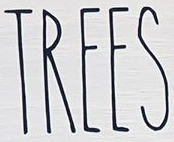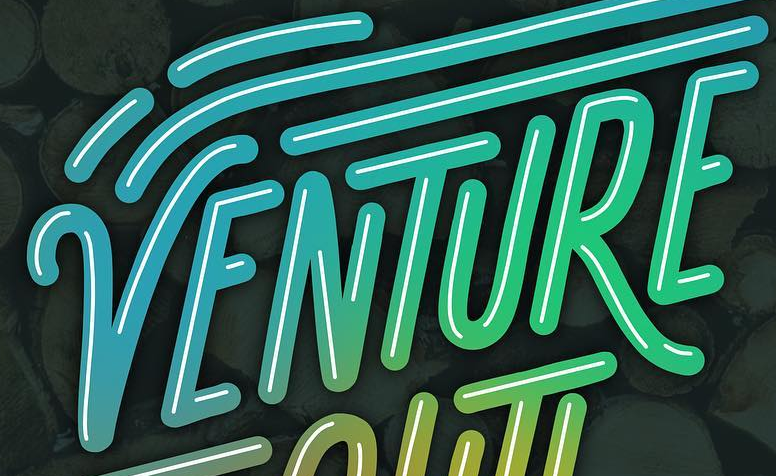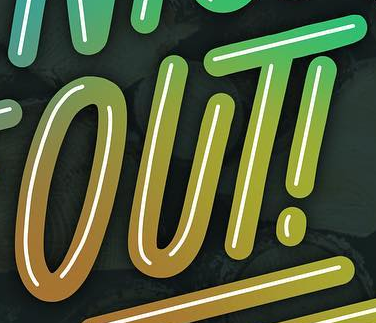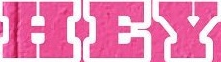Read the text content from these images in order, separated by a semicolon. TREES; VENTURE; OUT!; HEY 